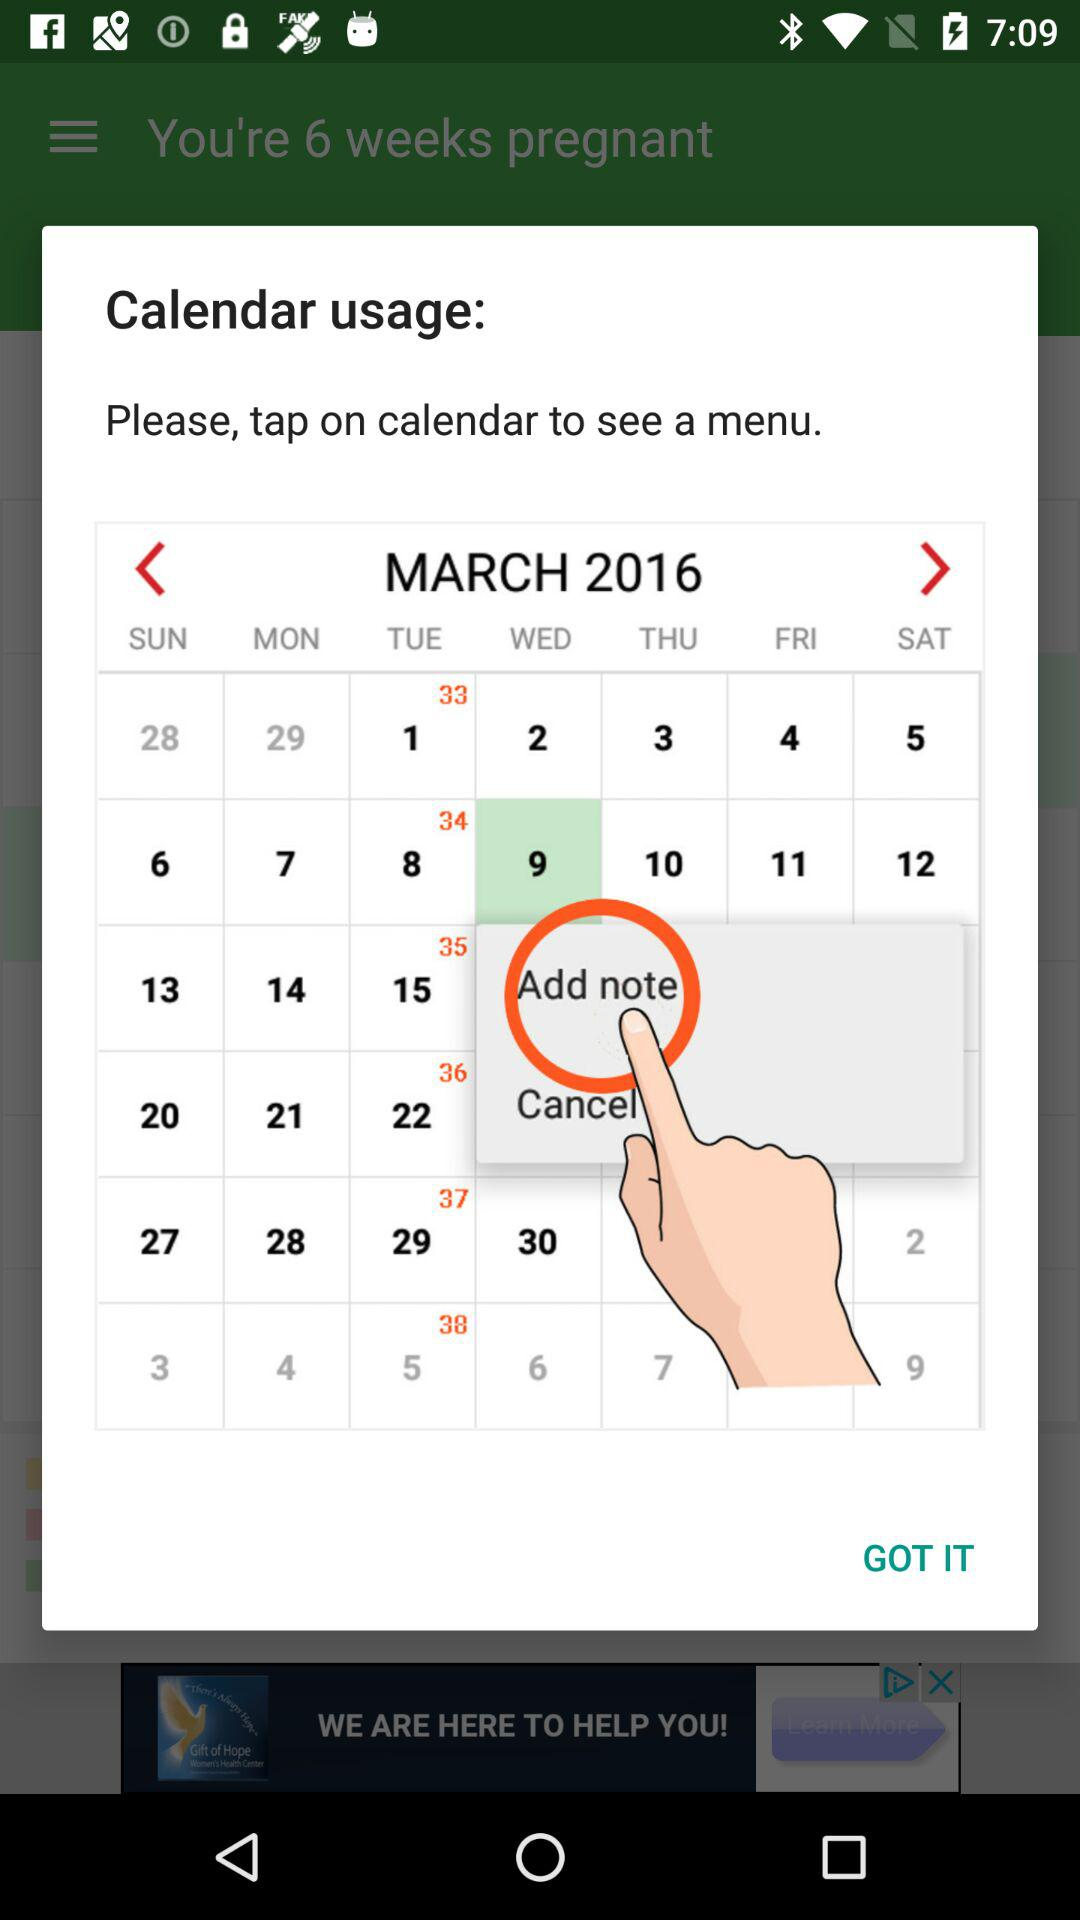What is the selected date? The selected date is Wednesday, March 9, 2016. 